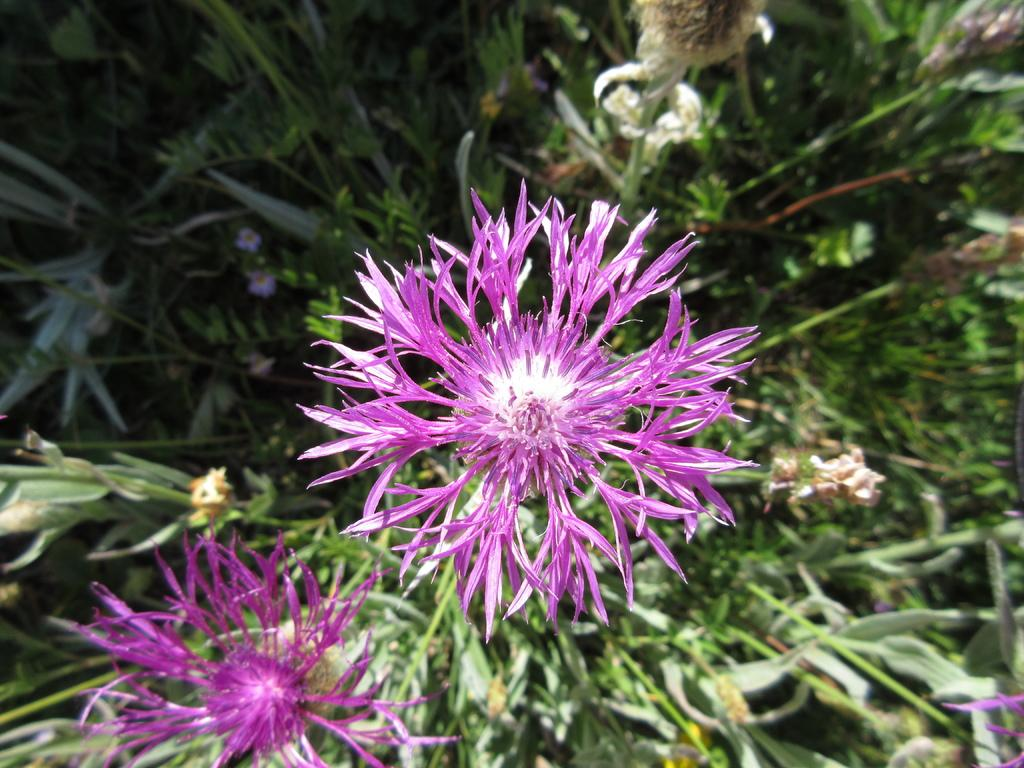What type of flowers can be seen in the image? There are purple color flowers in the image. What other type of vegetation is present in the image? There are green plants in the image. What type of support can be seen in the image? There is no support visible in the image; it only features purple flowers and green plants. Can you tell me how many chess pieces are present in the image? There are no chess pieces present in the image; it only features purple flowers and green plants. 